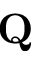Convert formula to latex. <formula><loc_0><loc_0><loc_500><loc_500>{ Q }</formula> 